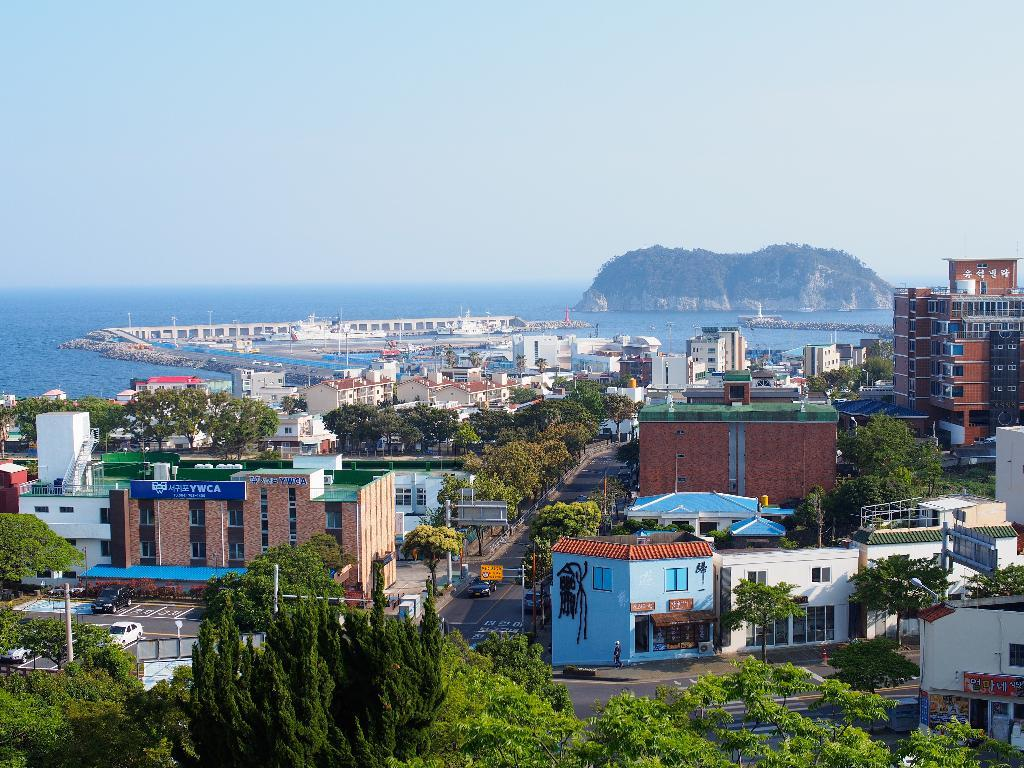What type of natural elements can be seen in the image? There are trees in the image. What type of man-made structures are visible in the image? There are buildings in the image. What type of transportation is present on the road in the image? There are vehicles on the road in the image. What type of vertical structures can be seen in the image? There are poles in the image. What type of geographical feature is visible in the background of the image? There is an island visible in the background of the image. What type of watercraft can be seen on the water in the background of the image? There are boats on water in the background of the image. What part of the natural environment is visible in the background of the image? The sky is visible in the background of the image. Can you tell me how many crows are sitting on the bulb in the image? There are no crows or bulbs present in the image. What type of hook is attached to the boat in the image? There are no hooks visible on the boats in the image. 